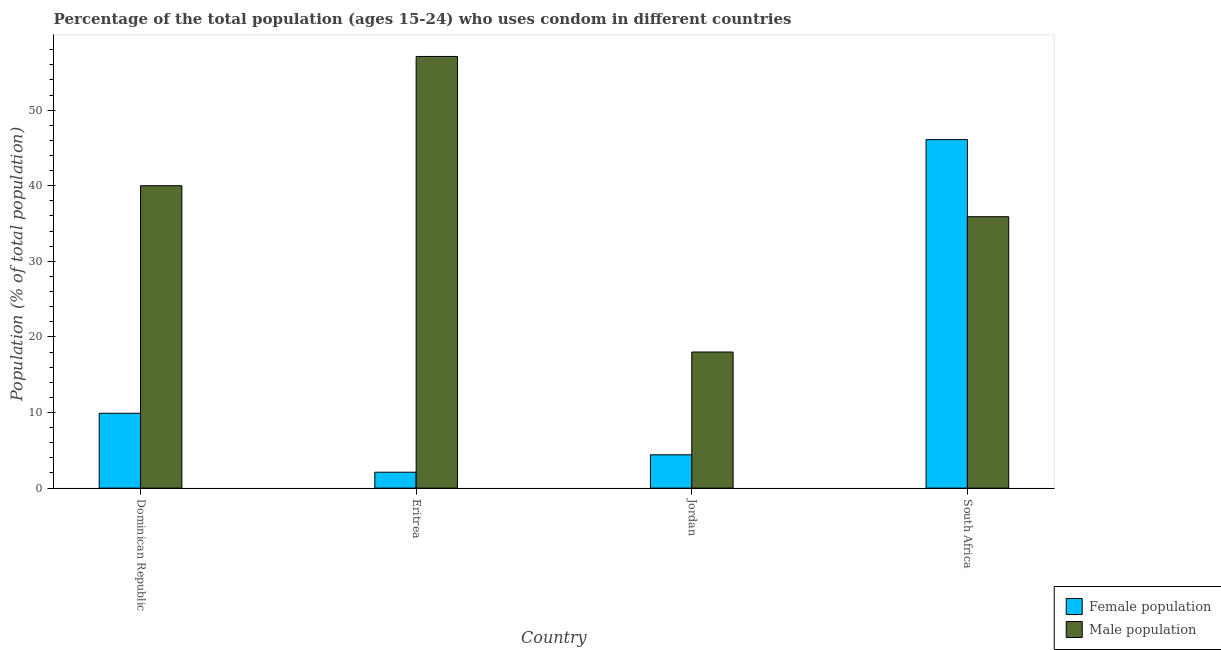How many different coloured bars are there?
Give a very brief answer. 2. How many groups of bars are there?
Your response must be concise. 4. Are the number of bars on each tick of the X-axis equal?
Make the answer very short. Yes. How many bars are there on the 2nd tick from the left?
Your answer should be compact. 2. What is the label of the 2nd group of bars from the left?
Your response must be concise. Eritrea. Across all countries, what is the maximum male population?
Ensure brevity in your answer.  57.1. In which country was the female population maximum?
Offer a terse response. South Africa. In which country was the female population minimum?
Make the answer very short. Eritrea. What is the total male population in the graph?
Your answer should be very brief. 151. What is the difference between the female population in Dominican Republic and that in Eritrea?
Provide a short and direct response. 7.8. What is the difference between the female population in South Africa and the male population in Eritrea?
Provide a succinct answer. -11. What is the average male population per country?
Offer a very short reply. 37.75. What is the difference between the female population and male population in Eritrea?
Your answer should be very brief. -55. What is the ratio of the female population in Dominican Republic to that in South Africa?
Your answer should be very brief. 0.21. Is the female population in Eritrea less than that in South Africa?
Your answer should be very brief. Yes. What is the difference between the highest and the lowest male population?
Make the answer very short. 39.1. In how many countries, is the female population greater than the average female population taken over all countries?
Your answer should be very brief. 1. What does the 2nd bar from the left in Eritrea represents?
Make the answer very short. Male population. What does the 2nd bar from the right in Eritrea represents?
Give a very brief answer. Female population. What is the difference between two consecutive major ticks on the Y-axis?
Provide a succinct answer. 10. Does the graph contain any zero values?
Keep it short and to the point. No. Does the graph contain grids?
Ensure brevity in your answer.  No. Where does the legend appear in the graph?
Offer a very short reply. Bottom right. How are the legend labels stacked?
Provide a succinct answer. Vertical. What is the title of the graph?
Provide a short and direct response. Percentage of the total population (ages 15-24) who uses condom in different countries. Does "Techinal cooperation" appear as one of the legend labels in the graph?
Ensure brevity in your answer.  No. What is the label or title of the X-axis?
Offer a very short reply. Country. What is the label or title of the Y-axis?
Make the answer very short. Population (% of total population) . What is the Population (% of total population)  of Male population in Dominican Republic?
Offer a terse response. 40. What is the Population (% of total population)  in Male population in Eritrea?
Offer a terse response. 57.1. What is the Population (% of total population)  of Female population in Jordan?
Make the answer very short. 4.4. What is the Population (% of total population)  in Male population in Jordan?
Provide a succinct answer. 18. What is the Population (% of total population)  of Female population in South Africa?
Make the answer very short. 46.1. What is the Population (% of total population)  of Male population in South Africa?
Keep it short and to the point. 35.9. Across all countries, what is the maximum Population (% of total population)  of Female population?
Give a very brief answer. 46.1. Across all countries, what is the maximum Population (% of total population)  of Male population?
Ensure brevity in your answer.  57.1. Across all countries, what is the minimum Population (% of total population)  in Female population?
Offer a terse response. 2.1. What is the total Population (% of total population)  of Female population in the graph?
Provide a succinct answer. 62.5. What is the total Population (% of total population)  of Male population in the graph?
Your answer should be compact. 151. What is the difference between the Population (% of total population)  of Female population in Dominican Republic and that in Eritrea?
Make the answer very short. 7.8. What is the difference between the Population (% of total population)  in Male population in Dominican Republic and that in Eritrea?
Keep it short and to the point. -17.1. What is the difference between the Population (% of total population)  of Female population in Dominican Republic and that in South Africa?
Your answer should be very brief. -36.2. What is the difference between the Population (% of total population)  in Male population in Dominican Republic and that in South Africa?
Provide a short and direct response. 4.1. What is the difference between the Population (% of total population)  in Female population in Eritrea and that in Jordan?
Provide a succinct answer. -2.3. What is the difference between the Population (% of total population)  in Male population in Eritrea and that in Jordan?
Provide a succinct answer. 39.1. What is the difference between the Population (% of total population)  in Female population in Eritrea and that in South Africa?
Offer a terse response. -44. What is the difference between the Population (% of total population)  of Male population in Eritrea and that in South Africa?
Your response must be concise. 21.2. What is the difference between the Population (% of total population)  in Female population in Jordan and that in South Africa?
Offer a very short reply. -41.7. What is the difference between the Population (% of total population)  of Male population in Jordan and that in South Africa?
Offer a very short reply. -17.9. What is the difference between the Population (% of total population)  of Female population in Dominican Republic and the Population (% of total population)  of Male population in Eritrea?
Keep it short and to the point. -47.2. What is the difference between the Population (% of total population)  of Female population in Dominican Republic and the Population (% of total population)  of Male population in Jordan?
Your response must be concise. -8.1. What is the difference between the Population (% of total population)  of Female population in Dominican Republic and the Population (% of total population)  of Male population in South Africa?
Your response must be concise. -26. What is the difference between the Population (% of total population)  in Female population in Eritrea and the Population (% of total population)  in Male population in Jordan?
Provide a short and direct response. -15.9. What is the difference between the Population (% of total population)  in Female population in Eritrea and the Population (% of total population)  in Male population in South Africa?
Ensure brevity in your answer.  -33.8. What is the difference between the Population (% of total population)  in Female population in Jordan and the Population (% of total population)  in Male population in South Africa?
Your answer should be very brief. -31.5. What is the average Population (% of total population)  of Female population per country?
Your response must be concise. 15.62. What is the average Population (% of total population)  in Male population per country?
Provide a short and direct response. 37.75. What is the difference between the Population (% of total population)  in Female population and Population (% of total population)  in Male population in Dominican Republic?
Provide a succinct answer. -30.1. What is the difference between the Population (% of total population)  of Female population and Population (% of total population)  of Male population in Eritrea?
Give a very brief answer. -55. What is the ratio of the Population (% of total population)  in Female population in Dominican Republic to that in Eritrea?
Ensure brevity in your answer.  4.71. What is the ratio of the Population (% of total population)  of Male population in Dominican Republic to that in Eritrea?
Provide a short and direct response. 0.7. What is the ratio of the Population (% of total population)  in Female population in Dominican Republic to that in Jordan?
Provide a succinct answer. 2.25. What is the ratio of the Population (% of total population)  of Male population in Dominican Republic to that in Jordan?
Give a very brief answer. 2.22. What is the ratio of the Population (% of total population)  in Female population in Dominican Republic to that in South Africa?
Offer a very short reply. 0.21. What is the ratio of the Population (% of total population)  of Male population in Dominican Republic to that in South Africa?
Your response must be concise. 1.11. What is the ratio of the Population (% of total population)  in Female population in Eritrea to that in Jordan?
Offer a terse response. 0.48. What is the ratio of the Population (% of total population)  of Male population in Eritrea to that in Jordan?
Your answer should be very brief. 3.17. What is the ratio of the Population (% of total population)  in Female population in Eritrea to that in South Africa?
Your answer should be very brief. 0.05. What is the ratio of the Population (% of total population)  in Male population in Eritrea to that in South Africa?
Offer a terse response. 1.59. What is the ratio of the Population (% of total population)  of Female population in Jordan to that in South Africa?
Keep it short and to the point. 0.1. What is the ratio of the Population (% of total population)  in Male population in Jordan to that in South Africa?
Offer a terse response. 0.5. What is the difference between the highest and the second highest Population (% of total population)  in Female population?
Provide a short and direct response. 36.2. What is the difference between the highest and the second highest Population (% of total population)  of Male population?
Ensure brevity in your answer.  17.1. What is the difference between the highest and the lowest Population (% of total population)  in Female population?
Give a very brief answer. 44. What is the difference between the highest and the lowest Population (% of total population)  in Male population?
Your answer should be very brief. 39.1. 